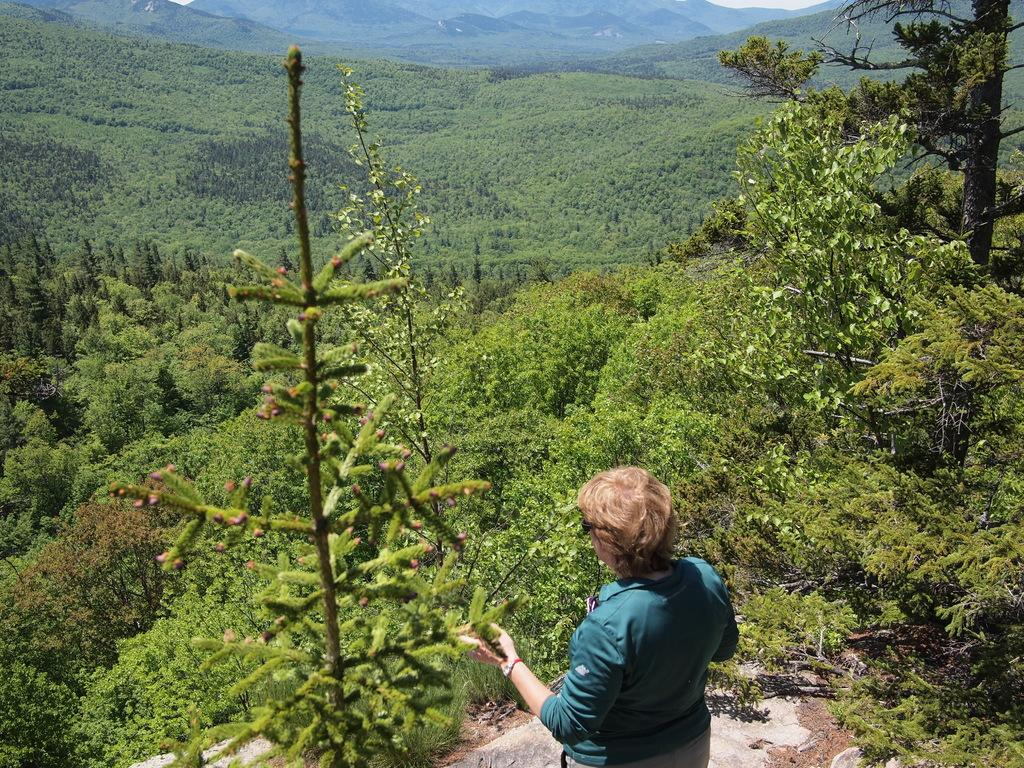What is the main subject of the image? There is a person standing in the image. What can be seen in the background of the image? There are trees visible in the image. What type of landscape feature is present in the image? There is a hill in the image. What advice is the person giving to the chickens in the image? There are no chickens present in the image, so no advice can be given to them. 